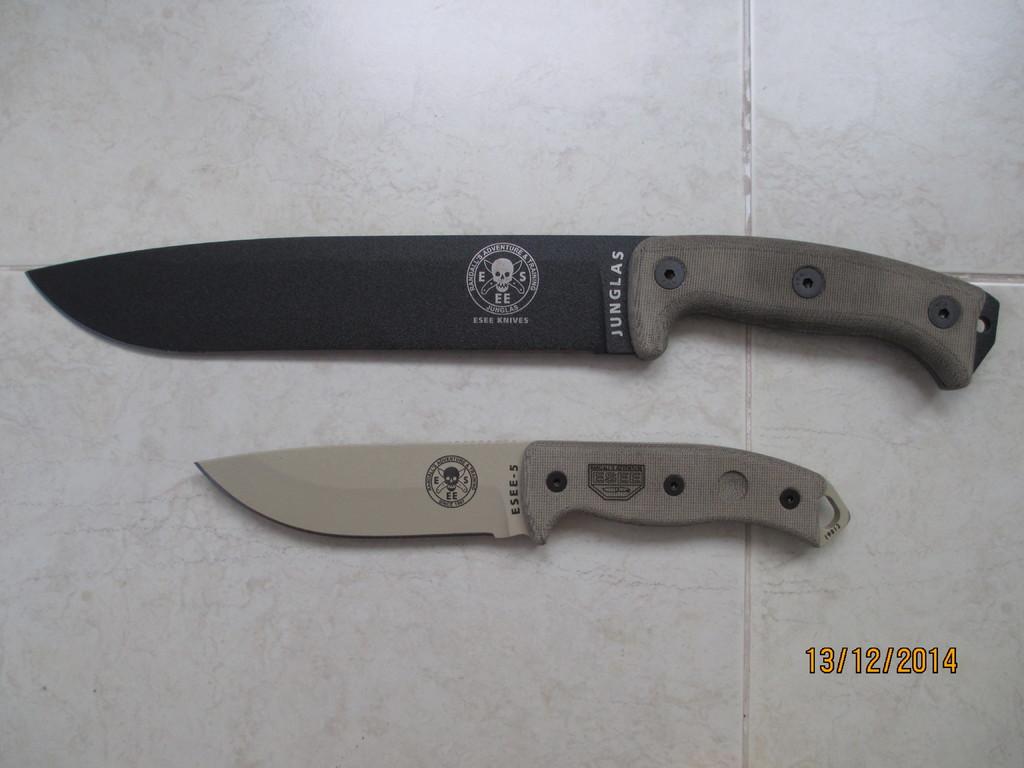What month was this photo taken?
Your answer should be compact. December. What is the name on the knife on top?
Provide a short and direct response. Junglas. 